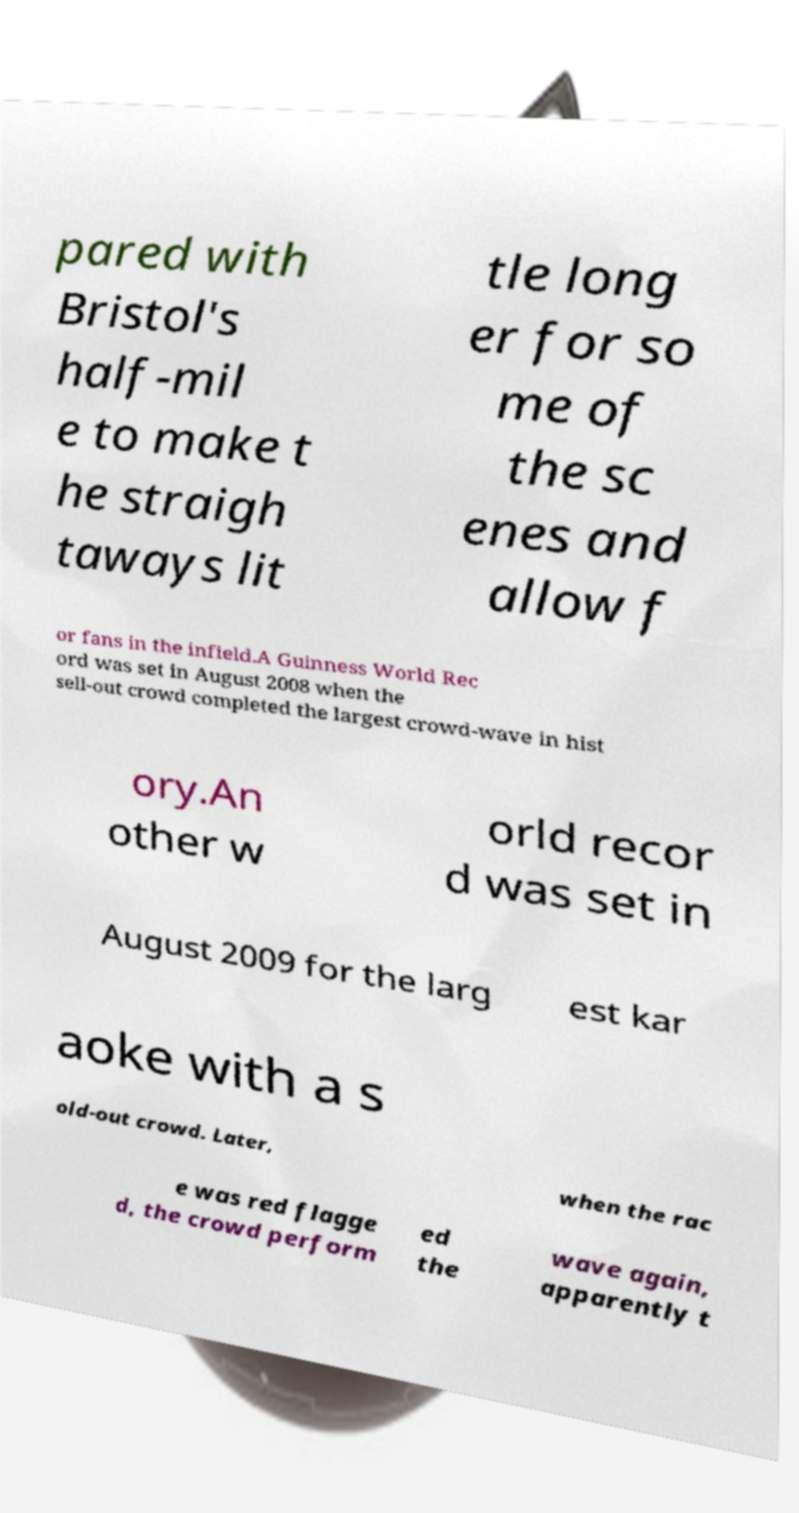Please identify and transcribe the text found in this image. pared with Bristol's half-mil e to make t he straigh taways lit tle long er for so me of the sc enes and allow f or fans in the infield.A Guinness World Rec ord was set in August 2008 when the sell-out crowd completed the largest crowd-wave in hist ory.An other w orld recor d was set in August 2009 for the larg est kar aoke with a s old-out crowd. Later, when the rac e was red flagge d, the crowd perform ed the wave again, apparently t 